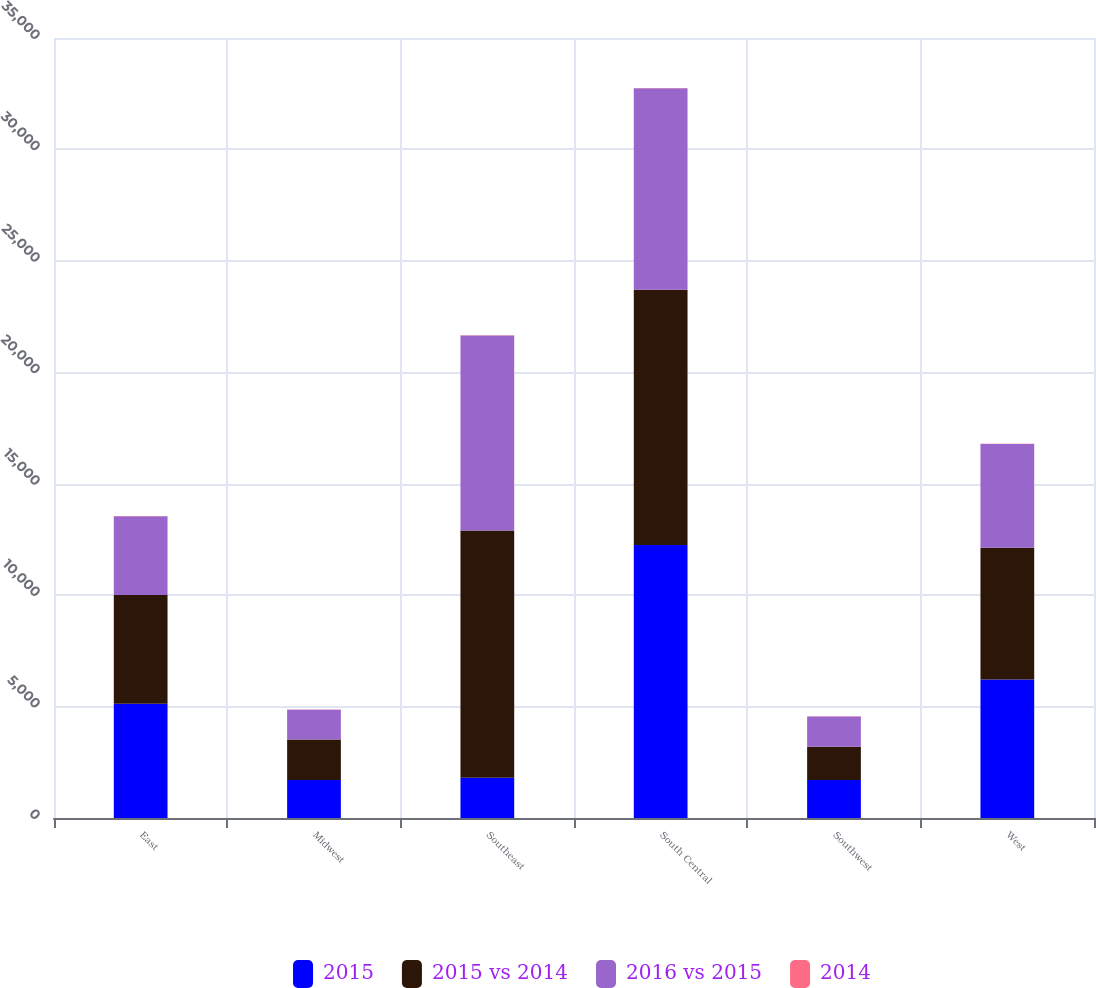Convert chart. <chart><loc_0><loc_0><loc_500><loc_500><stacked_bar_chart><ecel><fcel>East<fcel>Midwest<fcel>Southeast<fcel>South Central<fcel>Southwest<fcel>West<nl><fcel>2015<fcel>5126<fcel>1708<fcel>1811<fcel>12249<fcel>1703<fcel>6220<nl><fcel>2015 vs 2014<fcel>4880<fcel>1811<fcel>11093<fcel>11455<fcel>1499<fcel>5910<nl><fcel>2016 vs 2015<fcel>3537<fcel>1342<fcel>8743<fcel>9046<fcel>1348<fcel>4654<nl><fcel>2014<fcel>5<fcel>6<fcel>20<fcel>7<fcel>14<fcel>5<nl></chart> 